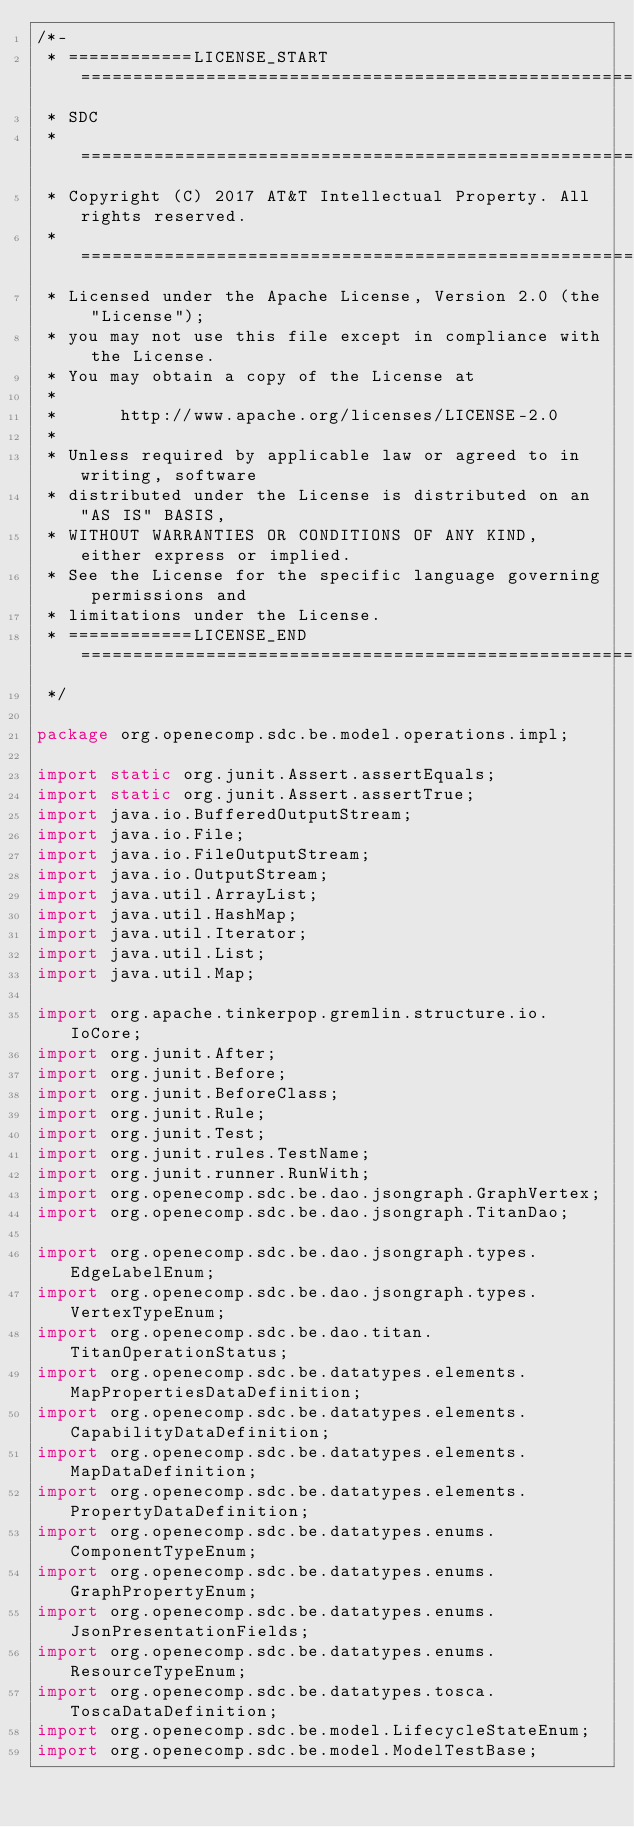Convert code to text. <code><loc_0><loc_0><loc_500><loc_500><_Java_>/*-
 * ============LICENSE_START=======================================================
 * SDC
 * ================================================================================
 * Copyright (C) 2017 AT&T Intellectual Property. All rights reserved.
 * ================================================================================
 * Licensed under the Apache License, Version 2.0 (the "License");
 * you may not use this file except in compliance with the License.
 * You may obtain a copy of the License at
 * 
 *      http://www.apache.org/licenses/LICENSE-2.0
 * 
 * Unless required by applicable law or agreed to in writing, software
 * distributed under the License is distributed on an "AS IS" BASIS,
 * WITHOUT WARRANTIES OR CONDITIONS OF ANY KIND, either express or implied.
 * See the License for the specific language governing permissions and
 * limitations under the License.
 * ============LICENSE_END=========================================================
 */

package org.openecomp.sdc.be.model.operations.impl;

import static org.junit.Assert.assertEquals;
import static org.junit.Assert.assertTrue;
import java.io.BufferedOutputStream;
import java.io.File;
import java.io.FileOutputStream;
import java.io.OutputStream;
import java.util.ArrayList;
import java.util.HashMap;
import java.util.Iterator;
import java.util.List;
import java.util.Map;

import org.apache.tinkerpop.gremlin.structure.io.IoCore;
import org.junit.After;
import org.junit.Before;
import org.junit.BeforeClass;
import org.junit.Rule;
import org.junit.Test;
import org.junit.rules.TestName;
import org.junit.runner.RunWith;
import org.openecomp.sdc.be.dao.jsongraph.GraphVertex;
import org.openecomp.sdc.be.dao.jsongraph.TitanDao;

import org.openecomp.sdc.be.dao.jsongraph.types.EdgeLabelEnum;
import org.openecomp.sdc.be.dao.jsongraph.types.VertexTypeEnum;
import org.openecomp.sdc.be.dao.titan.TitanOperationStatus;
import org.openecomp.sdc.be.datatypes.elements.MapPropertiesDataDefinition;
import org.openecomp.sdc.be.datatypes.elements.CapabilityDataDefinition;
import org.openecomp.sdc.be.datatypes.elements.MapDataDefinition;
import org.openecomp.sdc.be.datatypes.elements.PropertyDataDefinition;
import org.openecomp.sdc.be.datatypes.enums.ComponentTypeEnum;
import org.openecomp.sdc.be.datatypes.enums.GraphPropertyEnum;
import org.openecomp.sdc.be.datatypes.enums.JsonPresentationFields;
import org.openecomp.sdc.be.datatypes.enums.ResourceTypeEnum;
import org.openecomp.sdc.be.datatypes.tosca.ToscaDataDefinition;
import org.openecomp.sdc.be.model.LifecycleStateEnum;
import org.openecomp.sdc.be.model.ModelTestBase;</code> 